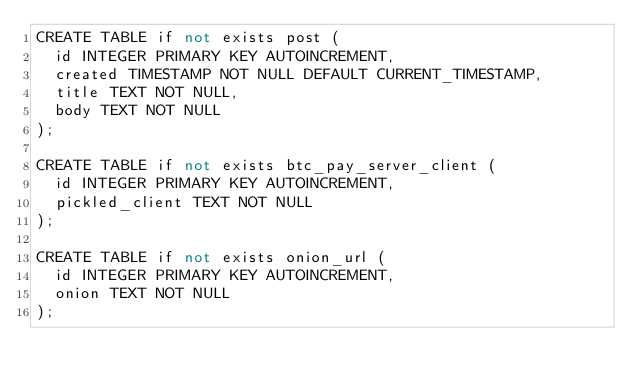Convert code to text. <code><loc_0><loc_0><loc_500><loc_500><_SQL_>CREATE TABLE if not exists post (
  id INTEGER PRIMARY KEY AUTOINCREMENT,
  created TIMESTAMP NOT NULL DEFAULT CURRENT_TIMESTAMP,
  title TEXT NOT NULL,
  body TEXT NOT NULL
);

CREATE TABLE if not exists btc_pay_server_client (
  id INTEGER PRIMARY KEY AUTOINCREMENT,
  pickled_client TEXT NOT NULL
);

CREATE TABLE if not exists onion_url (
  id INTEGER PRIMARY KEY AUTOINCREMENT,
  onion TEXT NOT NULL
);</code> 